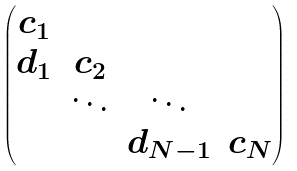<formula> <loc_0><loc_0><loc_500><loc_500>\begin{pmatrix} c _ { 1 } \\ d _ { 1 } & c _ { 2 } \\ & \ddots & \ddots \\ & & d _ { N - 1 } & c _ { N } \end{pmatrix}</formula> 